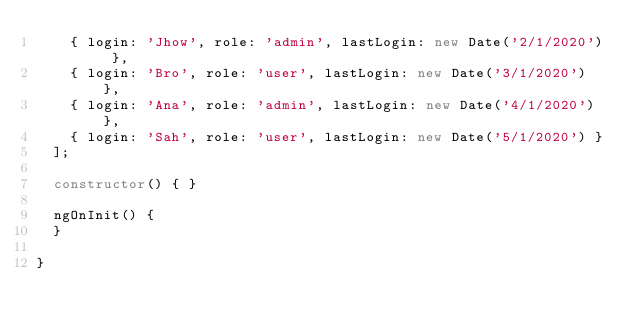<code> <loc_0><loc_0><loc_500><loc_500><_TypeScript_>    { login: 'Jhow', role: 'admin', lastLogin: new Date('2/1/2020') },
    { login: 'Bro', role: 'user', lastLogin: new Date('3/1/2020') },
    { login: 'Ana', role: 'admin', lastLogin: new Date('4/1/2020') },
    { login: 'Sah', role: 'user', lastLogin: new Date('5/1/2020') }
  ];

  constructor() { }

  ngOnInit() {
  }

}
</code> 